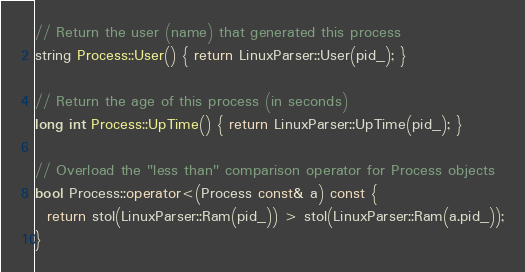<code> <loc_0><loc_0><loc_500><loc_500><_C++_>// Return the user (name) that generated this process
string Process::User() { return LinuxParser::User(pid_); }

// Return the age of this process (in seconds)
long int Process::UpTime() { return LinuxParser::UpTime(pid_); }

// Overload the "less than" comparison operator for Process objects
bool Process::operator<(Process const& a) const { 
  return stol(LinuxParser::Ram(pid_)) > stol(LinuxParser::Ram(a.pid_));
}
</code> 